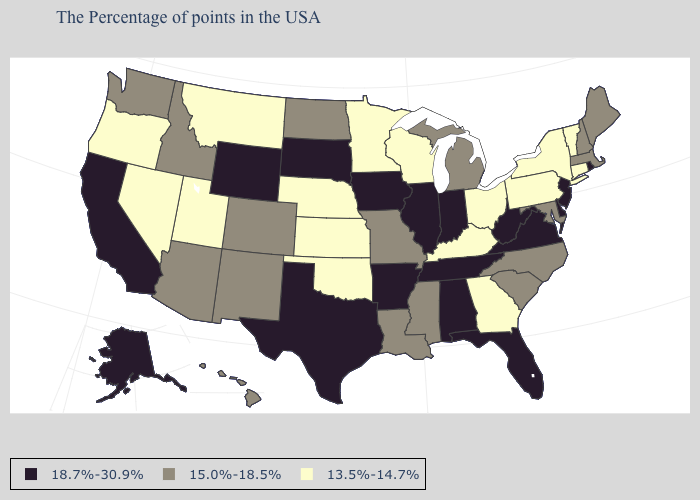Name the states that have a value in the range 13.5%-14.7%?
Be succinct. Vermont, Connecticut, New York, Pennsylvania, Ohio, Georgia, Kentucky, Wisconsin, Minnesota, Kansas, Nebraska, Oklahoma, Utah, Montana, Nevada, Oregon. Name the states that have a value in the range 18.7%-30.9%?
Answer briefly. Rhode Island, New Jersey, Delaware, Virginia, West Virginia, Florida, Indiana, Alabama, Tennessee, Illinois, Arkansas, Iowa, Texas, South Dakota, Wyoming, California, Alaska. What is the value of Arizona?
Be succinct. 15.0%-18.5%. Among the states that border Nebraska , which have the lowest value?
Short answer required. Kansas. Name the states that have a value in the range 15.0%-18.5%?
Be succinct. Maine, Massachusetts, New Hampshire, Maryland, North Carolina, South Carolina, Michigan, Mississippi, Louisiana, Missouri, North Dakota, Colorado, New Mexico, Arizona, Idaho, Washington, Hawaii. What is the value of Pennsylvania?
Be succinct. 13.5%-14.7%. What is the value of Arkansas?
Write a very short answer. 18.7%-30.9%. What is the highest value in states that border Kentucky?
Concise answer only. 18.7%-30.9%. Name the states that have a value in the range 18.7%-30.9%?
Give a very brief answer. Rhode Island, New Jersey, Delaware, Virginia, West Virginia, Florida, Indiana, Alabama, Tennessee, Illinois, Arkansas, Iowa, Texas, South Dakota, Wyoming, California, Alaska. What is the value of Delaware?
Write a very short answer. 18.7%-30.9%. Name the states that have a value in the range 13.5%-14.7%?
Give a very brief answer. Vermont, Connecticut, New York, Pennsylvania, Ohio, Georgia, Kentucky, Wisconsin, Minnesota, Kansas, Nebraska, Oklahoma, Utah, Montana, Nevada, Oregon. Name the states that have a value in the range 15.0%-18.5%?
Be succinct. Maine, Massachusetts, New Hampshire, Maryland, North Carolina, South Carolina, Michigan, Mississippi, Louisiana, Missouri, North Dakota, Colorado, New Mexico, Arizona, Idaho, Washington, Hawaii. Does New Hampshire have the same value as Colorado?
Quick response, please. Yes. Name the states that have a value in the range 18.7%-30.9%?
Write a very short answer. Rhode Island, New Jersey, Delaware, Virginia, West Virginia, Florida, Indiana, Alabama, Tennessee, Illinois, Arkansas, Iowa, Texas, South Dakota, Wyoming, California, Alaska. Name the states that have a value in the range 13.5%-14.7%?
Give a very brief answer. Vermont, Connecticut, New York, Pennsylvania, Ohio, Georgia, Kentucky, Wisconsin, Minnesota, Kansas, Nebraska, Oklahoma, Utah, Montana, Nevada, Oregon. 